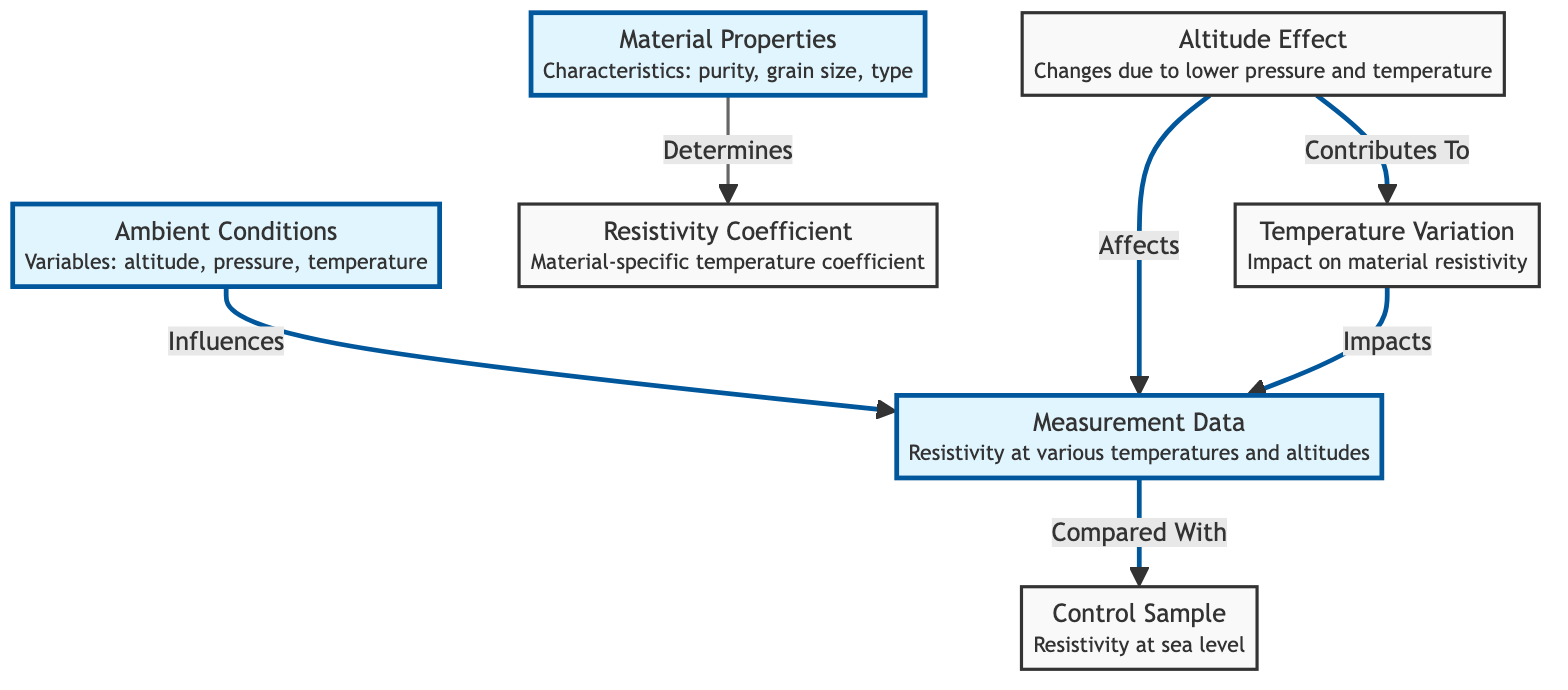What are the variables in ambient conditions? The diagram indicates that the ambient conditions involve altitude, pressure, and temperature as the primary variables. These are listed directly under the "Ambient Conditions" node in the diagram.
Answer: altitude, pressure, temperature How does material properties affect resistivity coefficient? According to the diagram, material properties determine the resistivity coefficient. This relationship is indicated by the arrow linking "Material Properties" to "Resistivity Coefficient."
Answer: Determines What does altitude effect contribute to? The diagram states that altitude effect contributes to temperature variation. This can be seen in the directional arrow leading from "Altitude Effect" to "Temperature Variation."
Answer: Temperature Variation How many main nodes are present in the diagram? By counting each distinct box in the diagram, such as "Ambient Conditions," "Material Properties," and others, we find there are a total of 6 main nodes represented.
Answer: 6 What data is compared with the control sample? The measurement data node is directly linked to the control sample node with an arrow labeled "Compared With," indicating that the measurement data is compared with the control sample.
Answer: Measurement Data How many edges are in the diagram? The edges are the connections between nodes, and by carefully counting, we can see there are a total of 5 directional arrows that connect various nodes in the diagram.
Answer: 5 What does temperature variation impact? The diagram specifies that temperature variation impacts measurement data, as indicated by the directed connection from "Temperature Variation" to "Measurement Data."
Answer: Measurement Data What influences the measurement data? The diagram explicitly shows that both ambient conditions and altitude effect influence the measurement data. These connections are demonstrated with arrows pointing towards the "Measurement Data" node.
Answer: Ambient Conditions, Altitude Effect 